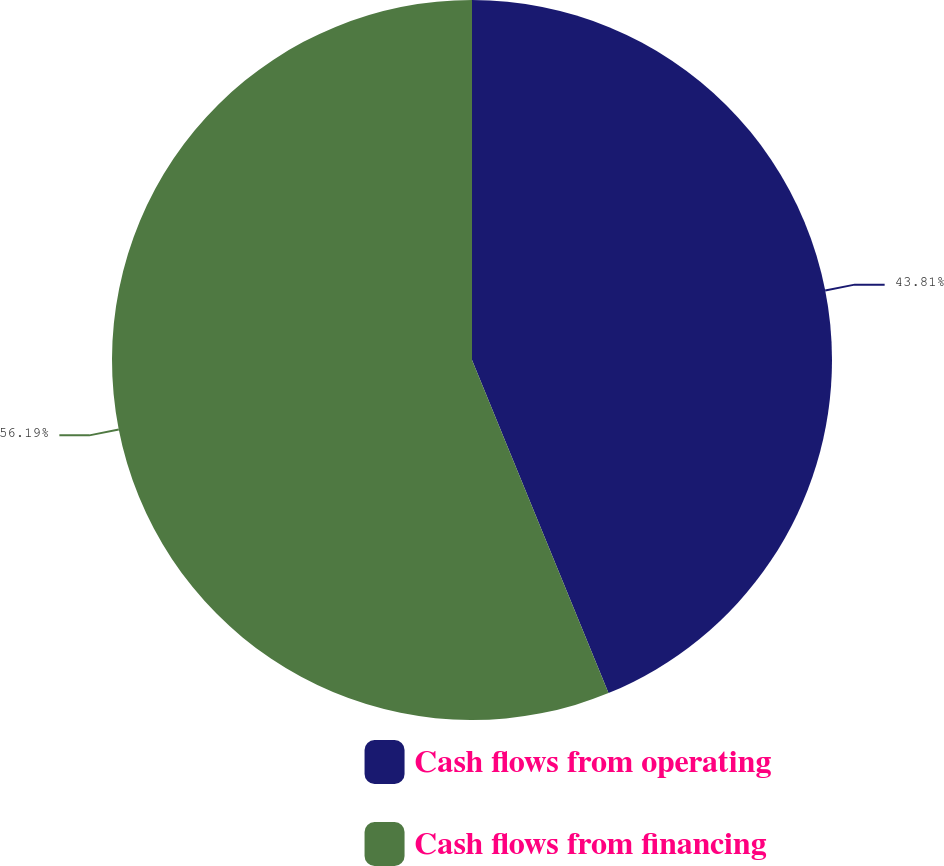Convert chart. <chart><loc_0><loc_0><loc_500><loc_500><pie_chart><fcel>Cash flows from operating<fcel>Cash flows from financing<nl><fcel>43.81%<fcel>56.19%<nl></chart> 